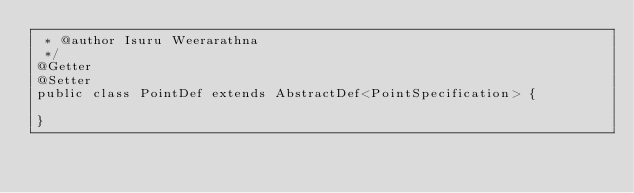<code> <loc_0><loc_0><loc_500><loc_500><_Java_> * @author Isuru Weerarathna
 */
@Getter
@Setter
public class PointDef extends AbstractDef<PointSpecification> {

}
</code> 